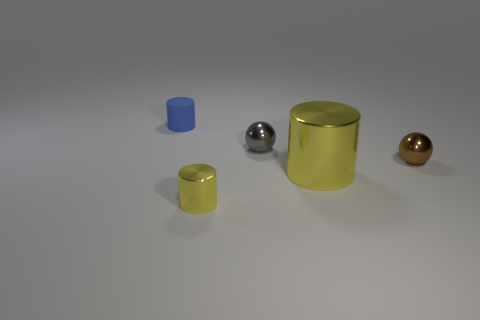Add 1 large yellow metal cylinders. How many objects exist? 6 Subtract all tiny cylinders. How many cylinders are left? 1 Subtract all cylinders. How many objects are left? 2 Subtract all blue cylinders. Subtract all cyan blocks. How many cylinders are left? 2 Subtract all gray cylinders. How many gray balls are left? 1 Subtract all large things. Subtract all brown rubber cylinders. How many objects are left? 4 Add 1 matte things. How many matte things are left? 2 Add 3 purple things. How many purple things exist? 3 Subtract all brown spheres. How many spheres are left? 1 Subtract 0 green balls. How many objects are left? 5 